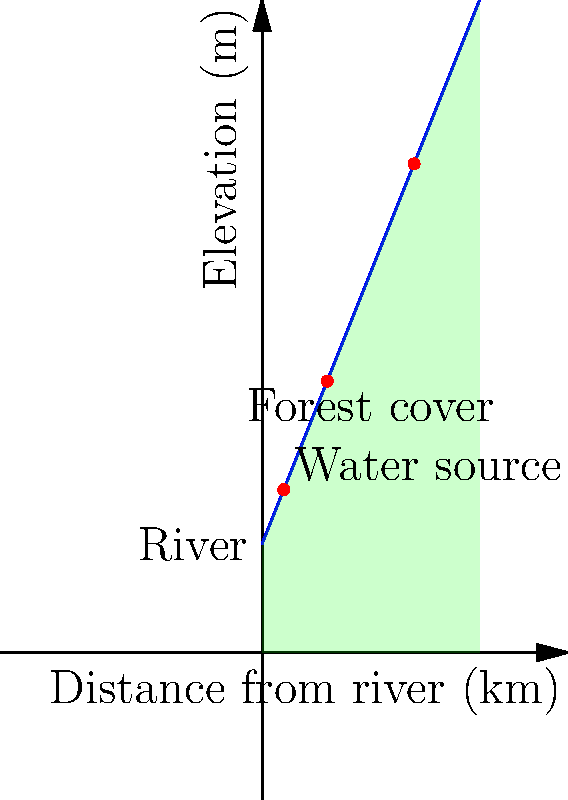Based on the topographic representation of a forested watershed, which water source is most vulnerable to deforestation impacts, and why? To determine which water source is most vulnerable to deforestation impacts, we need to consider several factors:

1. Proximity to the river: Water sources closer to the main river are generally less vulnerable as they have a shorter flow path and are less affected by changes in the surrounding landscape.

2. Elevation: Water sources at higher elevations are more susceptible to deforestation impacts as they rely on the forest cover to regulate water flow and prevent erosion.

3. Slope: Steeper slopes increase the vulnerability of water sources as deforestation can lead to more rapid runoff and erosion.

Analyzing the given topographic representation:

a. The first water source (10,75) is closest to the river and at the lowest elevation. It has the shortest flow path and is least affected by changes in the forest cover.

b. The second water source (30,125) is at a moderate elevation and distance from the river. It has some protection from the forest cover but could be impacted by upstream deforestation.

c. The third water source (70,225) is the furthest from the river and at the highest elevation. It has the longest flow path through the forest and is most dependent on the forest cover for water regulation and erosion prevention.

Given these factors, the water source at (70,225) is most vulnerable to deforestation impacts. Its high elevation and distance from the main river mean it relies heavily on the surrounding forest to maintain its water quality and quantity. Deforestation in this area would lead to increased runoff, erosion, and potential contamination of this water source.
Answer: The water source at (70,225), furthest from the river and highest in elevation. 